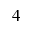<formula> <loc_0><loc_0><loc_500><loc_500>_ { 4 }</formula> 